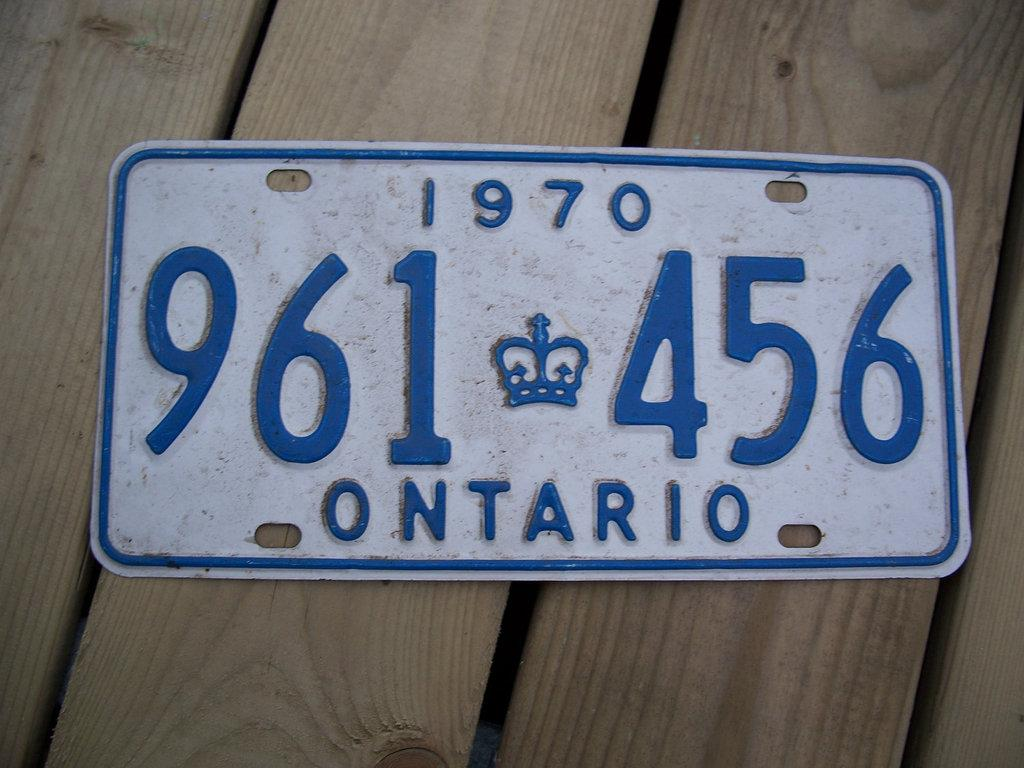<image>
Give a short and clear explanation of the subsequent image. A blue and white license plate from Ontario 